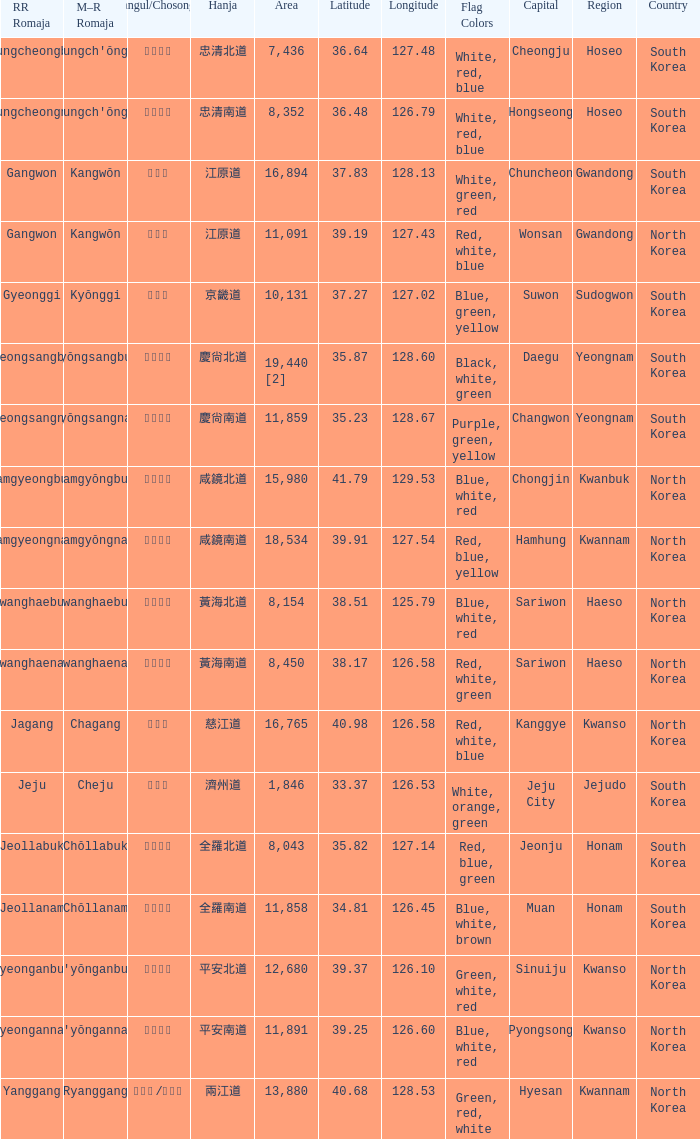What is the M-R Romaja for the province having a capital of Cheongju? Ch'ungch'ŏngbuk. 